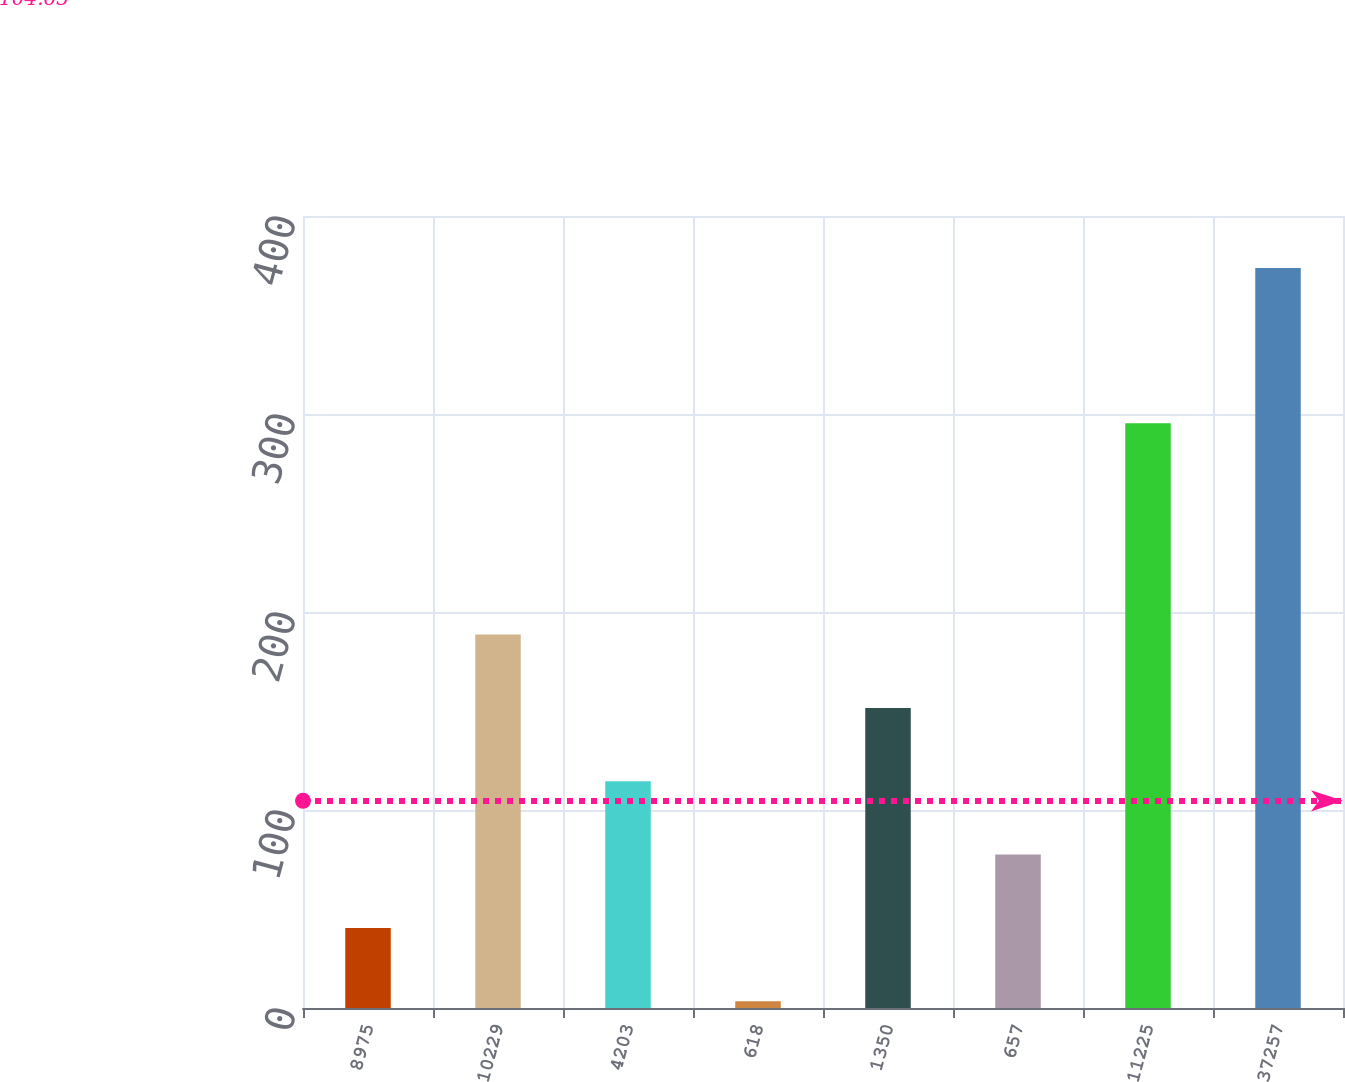<chart> <loc_0><loc_0><loc_500><loc_500><bar_chart><fcel>8975<fcel>10229<fcel>4203<fcel>618<fcel>1350<fcel>657<fcel>11225<fcel>37257<nl><fcel>40.44<fcel>188.6<fcel>114.52<fcel>3.4<fcel>151.56<fcel>77.48<fcel>295.3<fcel>373.8<nl></chart> 